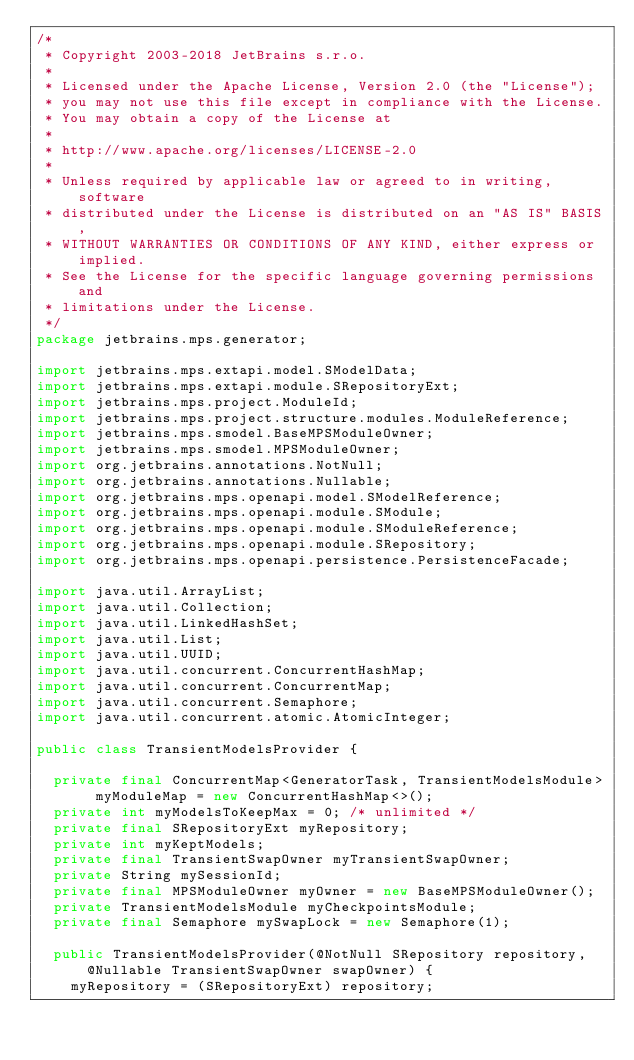Convert code to text. <code><loc_0><loc_0><loc_500><loc_500><_Java_>/*
 * Copyright 2003-2018 JetBrains s.r.o.
 *
 * Licensed under the Apache License, Version 2.0 (the "License");
 * you may not use this file except in compliance with the License.
 * You may obtain a copy of the License at
 *
 * http://www.apache.org/licenses/LICENSE-2.0
 *
 * Unless required by applicable law or agreed to in writing, software
 * distributed under the License is distributed on an "AS IS" BASIS,
 * WITHOUT WARRANTIES OR CONDITIONS OF ANY KIND, either express or implied.
 * See the License for the specific language governing permissions and
 * limitations under the License.
 */
package jetbrains.mps.generator;

import jetbrains.mps.extapi.model.SModelData;
import jetbrains.mps.extapi.module.SRepositoryExt;
import jetbrains.mps.project.ModuleId;
import jetbrains.mps.project.structure.modules.ModuleReference;
import jetbrains.mps.smodel.BaseMPSModuleOwner;
import jetbrains.mps.smodel.MPSModuleOwner;
import org.jetbrains.annotations.NotNull;
import org.jetbrains.annotations.Nullable;
import org.jetbrains.mps.openapi.model.SModelReference;
import org.jetbrains.mps.openapi.module.SModule;
import org.jetbrains.mps.openapi.module.SModuleReference;
import org.jetbrains.mps.openapi.module.SRepository;
import org.jetbrains.mps.openapi.persistence.PersistenceFacade;

import java.util.ArrayList;
import java.util.Collection;
import java.util.LinkedHashSet;
import java.util.List;
import java.util.UUID;
import java.util.concurrent.ConcurrentHashMap;
import java.util.concurrent.ConcurrentMap;
import java.util.concurrent.Semaphore;
import java.util.concurrent.atomic.AtomicInteger;

public class TransientModelsProvider {

  private final ConcurrentMap<GeneratorTask, TransientModelsModule> myModuleMap = new ConcurrentHashMap<>();
  private int myModelsToKeepMax = 0; /* unlimited */
  private final SRepositoryExt myRepository;
  private int myKeptModels;
  private final TransientSwapOwner myTransientSwapOwner;
  private String mySessionId;
  private final MPSModuleOwner myOwner = new BaseMPSModuleOwner();
  private TransientModelsModule myCheckpointsModule;
  private final Semaphore mySwapLock = new Semaphore(1);

  public TransientModelsProvider(@NotNull SRepository repository, @Nullable TransientSwapOwner swapOwner) {
    myRepository = (SRepositoryExt) repository;</code> 